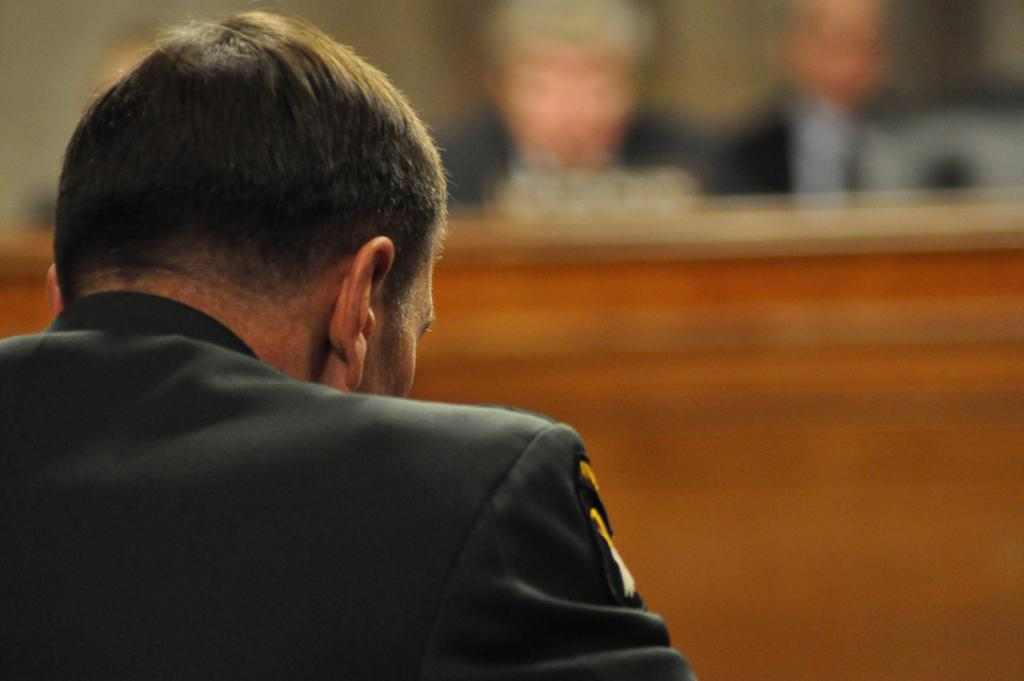What is present in the image? There is a person in the image. Can you describe the person's position in relation to the camera? The person is facing away from the camera. What can be observed about the person's attire? The person is wearing clothes. How would you describe the background of the image? The background of the image is blurred. What type of steel is visible on the person's face in the image? There is no steel or teeth visible on the person's face in the image. 